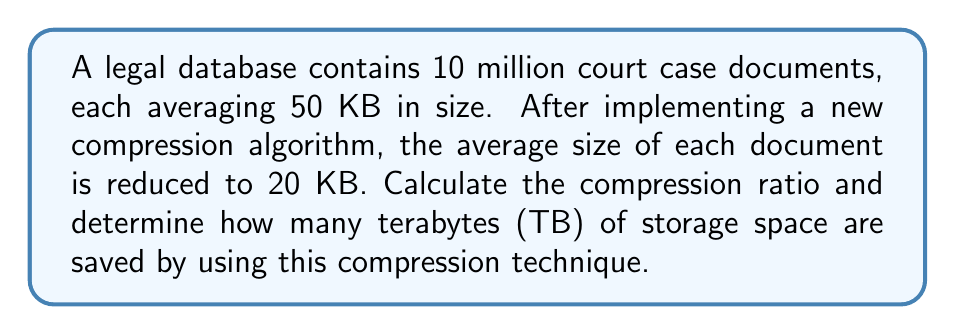Solve this math problem. To solve this problem, we'll follow these steps:

1. Calculate the original size of the database:
   Original size = Number of documents × Original average size
   $$ 10,000,000 \times 50 \text{ KB} = 500,000,000 \text{ KB} $$

2. Calculate the compressed size of the database:
   Compressed size = Number of documents × Compressed average size
   $$ 10,000,000 \times 20 \text{ KB} = 200,000,000 \text{ KB} $$

3. Calculate the compression ratio:
   Compression ratio = Original size ÷ Compressed size
   $$ \frac{500,000,000}{200,000,000} = 2.5 $$

4. Calculate the amount of storage space saved:
   Space saved = Original size - Compressed size
   $$ 500,000,000 \text{ KB} - 200,000,000 \text{ KB} = 300,000,000 \text{ KB} $$

5. Convert the saved space from KB to TB:
   1 TB = 1,000,000,000 KB
   Saved space in TB = Saved space in KB ÷ 1,000,000,000
   $$ \frac{300,000,000}{1,000,000,000} = 0.3 \text{ TB} $$
Answer: The compression ratio is 2.5:1, and the storage space saved is 0.3 TB. 